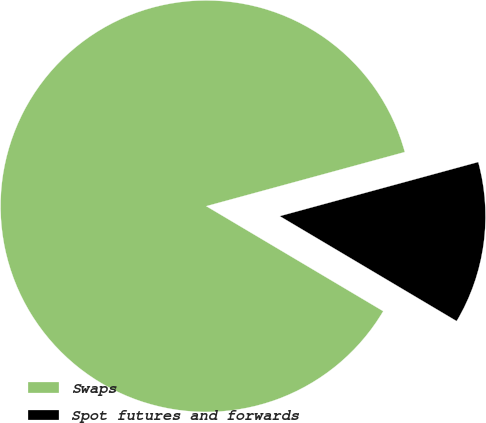Convert chart. <chart><loc_0><loc_0><loc_500><loc_500><pie_chart><fcel>Swaps<fcel>Spot futures and forwards<nl><fcel>87.24%<fcel>12.76%<nl></chart> 